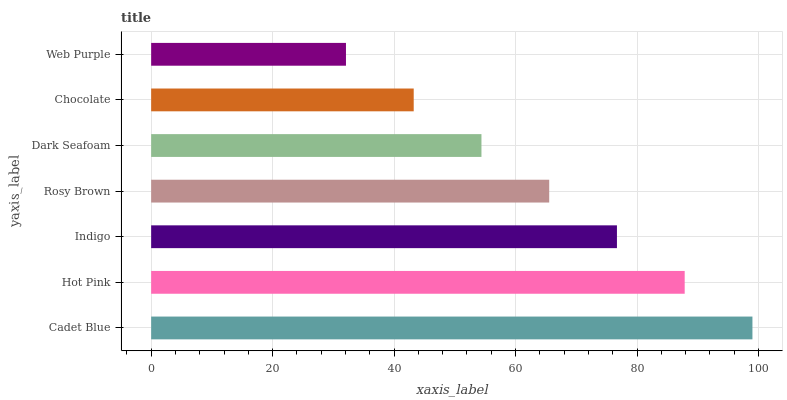Is Web Purple the minimum?
Answer yes or no. Yes. Is Cadet Blue the maximum?
Answer yes or no. Yes. Is Hot Pink the minimum?
Answer yes or no. No. Is Hot Pink the maximum?
Answer yes or no. No. Is Cadet Blue greater than Hot Pink?
Answer yes or no. Yes. Is Hot Pink less than Cadet Blue?
Answer yes or no. Yes. Is Hot Pink greater than Cadet Blue?
Answer yes or no. No. Is Cadet Blue less than Hot Pink?
Answer yes or no. No. Is Rosy Brown the high median?
Answer yes or no. Yes. Is Rosy Brown the low median?
Answer yes or no. Yes. Is Hot Pink the high median?
Answer yes or no. No. Is Dark Seafoam the low median?
Answer yes or no. No. 